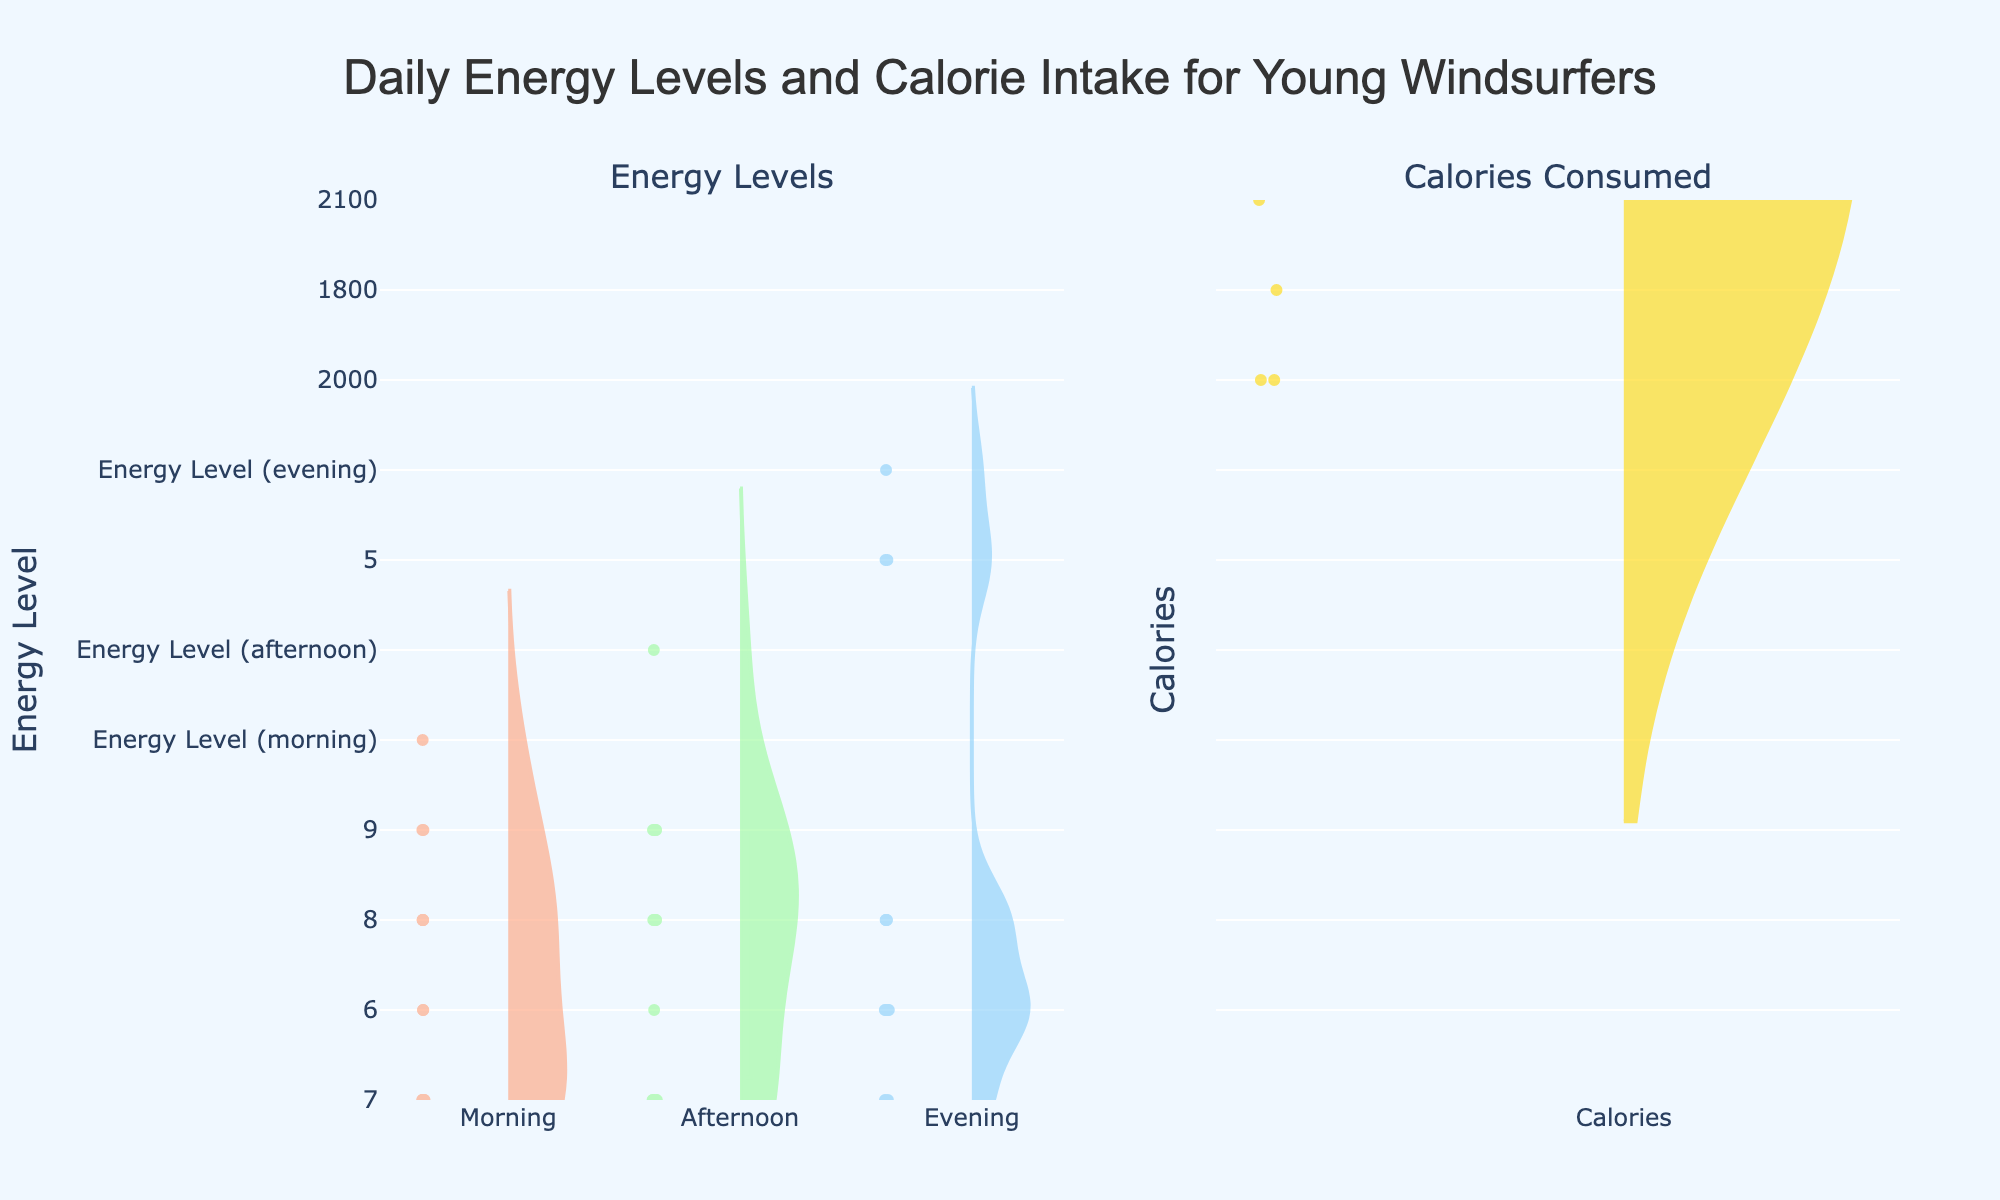What are the titles of the subplots in the figure? The figure is divided into two subplots, titled 'Energy Levels' and 'Calories Consumed'. The titles are provided at the top of each subplot.
Answer: Energy Levels, Calories Consumed What is the average energy level in the afternoon based on the figure? By observing the violin plot for the afternoon energy levels, we can visually estimate the average as being at the central horizontal line of the violin plot. The central tendency line for the afternoon energy levels appears to be at around 7.5.
Answer: Approximately 7.5 How many data points are displayed in the 'Calories Consumed' violin plot? The 'Calories Consumed' violin plot shows points within the plot, and each point represents a single data entry. Counting the points, we can see that there are 14 data points total.
Answer: 14 Which time of day has the highest median energy level? By comparing the three violin plots for morning, afternoon, and evening, we observe that the afternoon's central tendency (mean line) appears to be the highest among the three. Thus, afternoon has the highest median energy level.
Answer: Afternoon What is the range of calories consumed as displayed in the figure? The y-axis of the 'Calories Consumed' subplot ranges from 1500 to 2500 calories. This can be directly observed from the axis labels.
Answer: 1500 to 2500 Are there any outlier values in the 'Calories Consumed' subplot? Outlier values in a violin plot would appear as small standalone points well outside the main body of the distribution. In the 'Calories Consumed' subplot, there don't seem to be any points significantly distant from the main body of the distribution.
Answer: No Compare the variability of energy levels throughout the day. By observing the width of the violin plots, we can infer the variability of the energy levels. The afternoon plot is relatively narrow, indicating less variability, while the evening and morning plots are wider, indicating higher variability.
Answer: Morning and evening have higher variability compared to afternoon How does the average calorie intake compare to the average energy level in the evening? The mean line in the 'Calories Consumed' violin plot is around 2000 calories. For the evening energy level, the mean line appears to be around 6.5. These numbers are derived from the central tendency lines within the violin plots.
Answer: 2000 calories compared to 6.5 energy level 